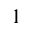Convert formula to latex. <formula><loc_0><loc_0><loc_500><loc_500>^ { 1 }</formula> 